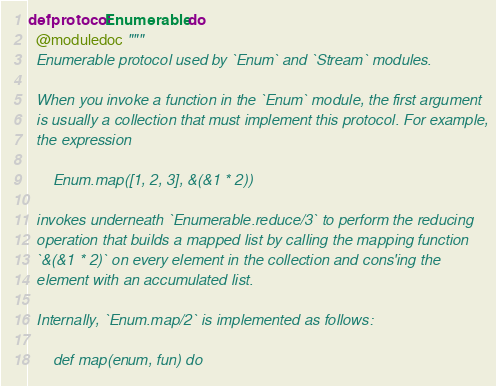Convert code to text. <code><loc_0><loc_0><loc_500><loc_500><_Elixir_>defprotocol Enumerable do
  @moduledoc """
  Enumerable protocol used by `Enum` and `Stream` modules.

  When you invoke a function in the `Enum` module, the first argument
  is usually a collection that must implement this protocol. For example,
  the expression

      Enum.map([1, 2, 3], &(&1 * 2))

  invokes underneath `Enumerable.reduce/3` to perform the reducing
  operation that builds a mapped list by calling the mapping function
  `&(&1 * 2)` on every element in the collection and cons'ing the
  element with an accumulated list.

  Internally, `Enum.map/2` is implemented as follows:

      def map(enum, fun) do</code> 